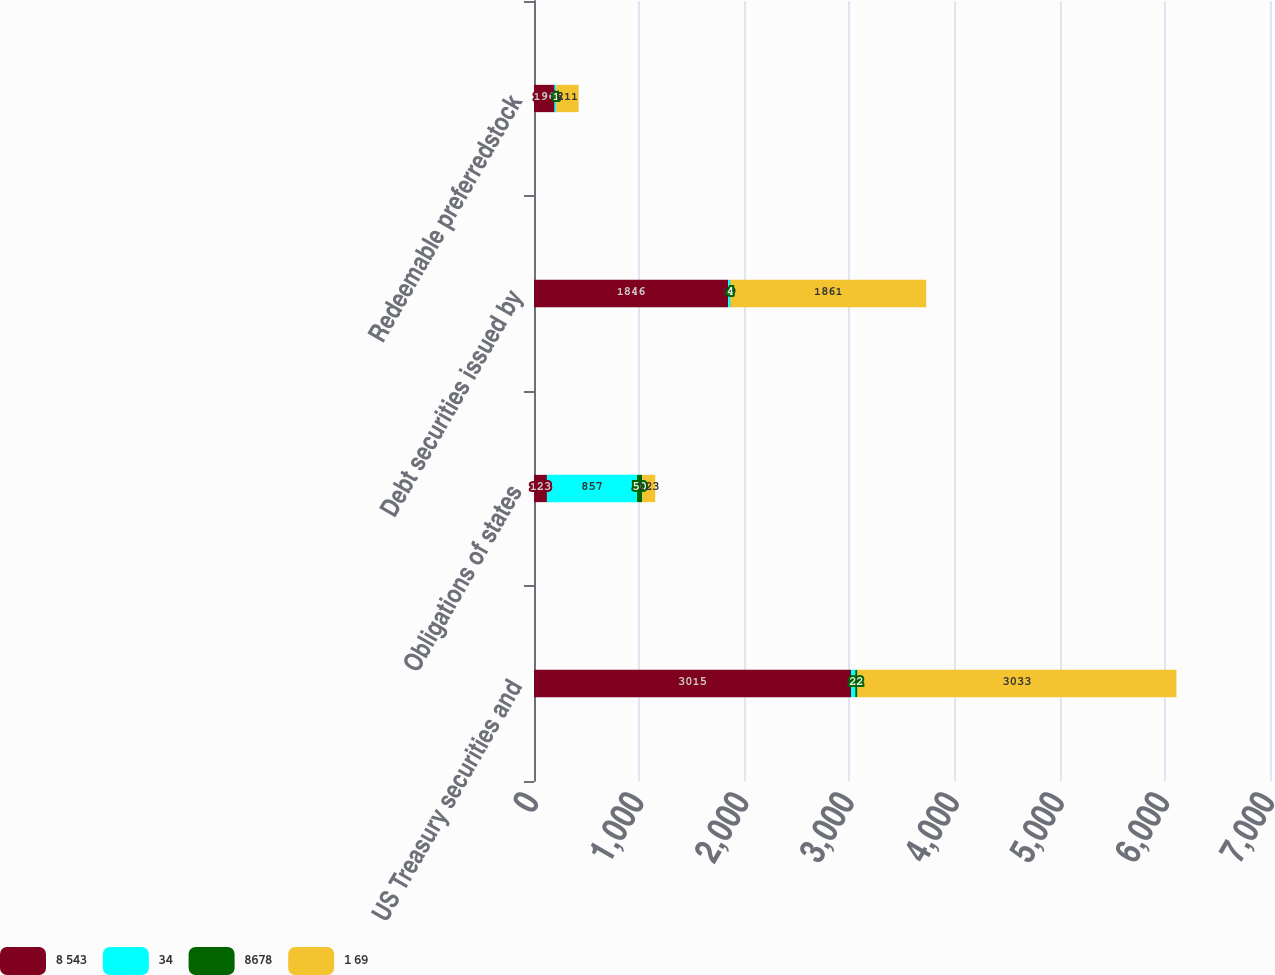Convert chart to OTSL. <chart><loc_0><loc_0><loc_500><loc_500><stacked_bar_chart><ecel><fcel>US Treasury securities and<fcel>Obligations of states<fcel>Debt securities issued by<fcel>Redeemable preferredstock<nl><fcel>8 543<fcel>3015<fcel>123<fcel>1846<fcel>196<nl><fcel>34<fcel>40<fcel>857<fcel>19<fcel>16<nl><fcel>8678<fcel>22<fcel>50<fcel>4<fcel>1<nl><fcel>1 69<fcel>3033<fcel>123<fcel>1861<fcel>211<nl></chart> 